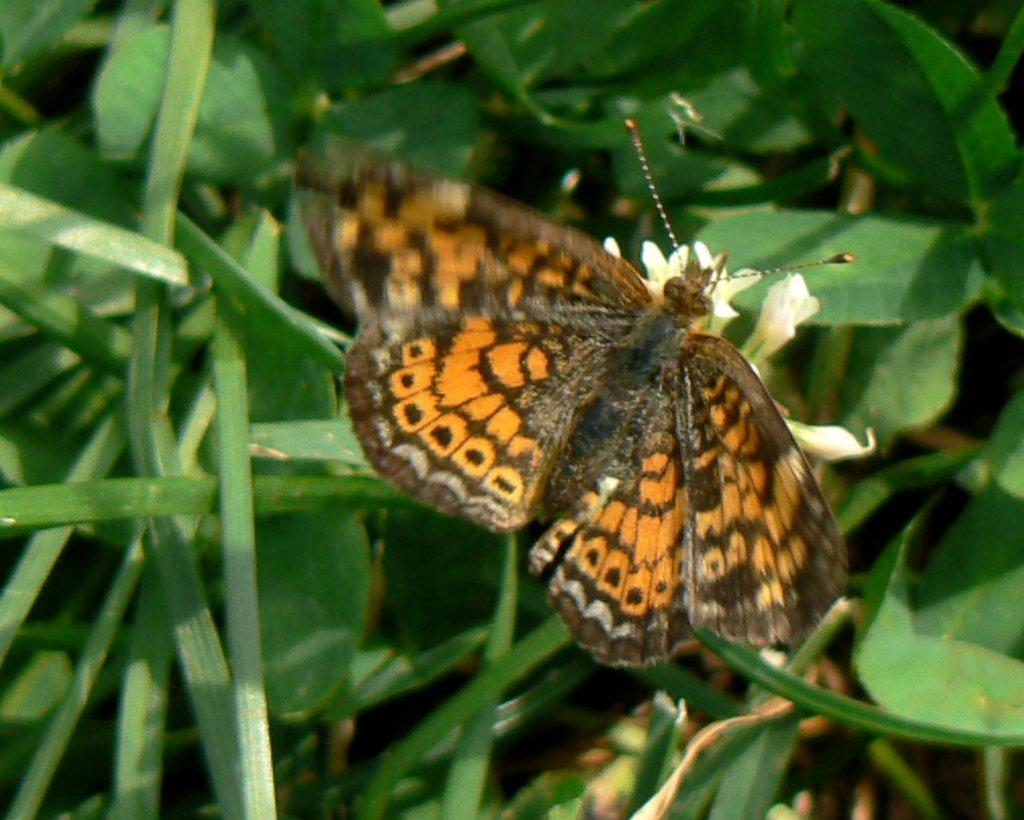What is the main subject in the foreground of the picture? There is an orange color butterfly in the foreground of the picture. What is the butterfly doing in the picture? The butterfly is on a flower. What can be seen in the background of the image? There are plants in the background of the image. What type of brake can be seen on the butterfly in the image? There is no brake present on the butterfly in the image, as it is a living organism and not a vehicle. 